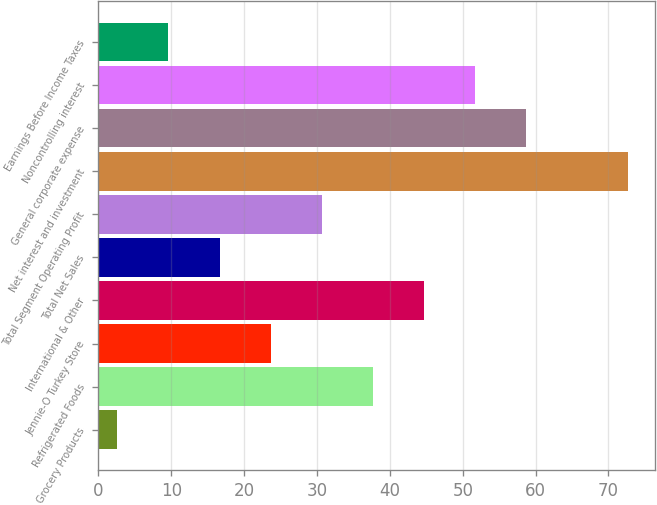Convert chart to OTSL. <chart><loc_0><loc_0><loc_500><loc_500><bar_chart><fcel>Grocery Products<fcel>Refrigerated Foods<fcel>Jennie-O Turkey Store<fcel>International & Other<fcel>Total Net Sales<fcel>Total Segment Operating Profit<fcel>Net interest and investment<fcel>General corporate expense<fcel>Noncontrolling interest<fcel>Earnings Before Income Taxes<nl><fcel>2.6<fcel>37.65<fcel>23.63<fcel>44.66<fcel>16.62<fcel>30.64<fcel>72.7<fcel>58.68<fcel>51.67<fcel>9.61<nl></chart> 